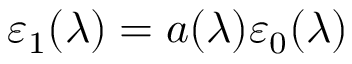Convert formula to latex. <formula><loc_0><loc_0><loc_500><loc_500>\varepsilon _ { 1 } ( \lambda ) = a ( \lambda ) \varepsilon _ { 0 } ( \lambda )</formula> 